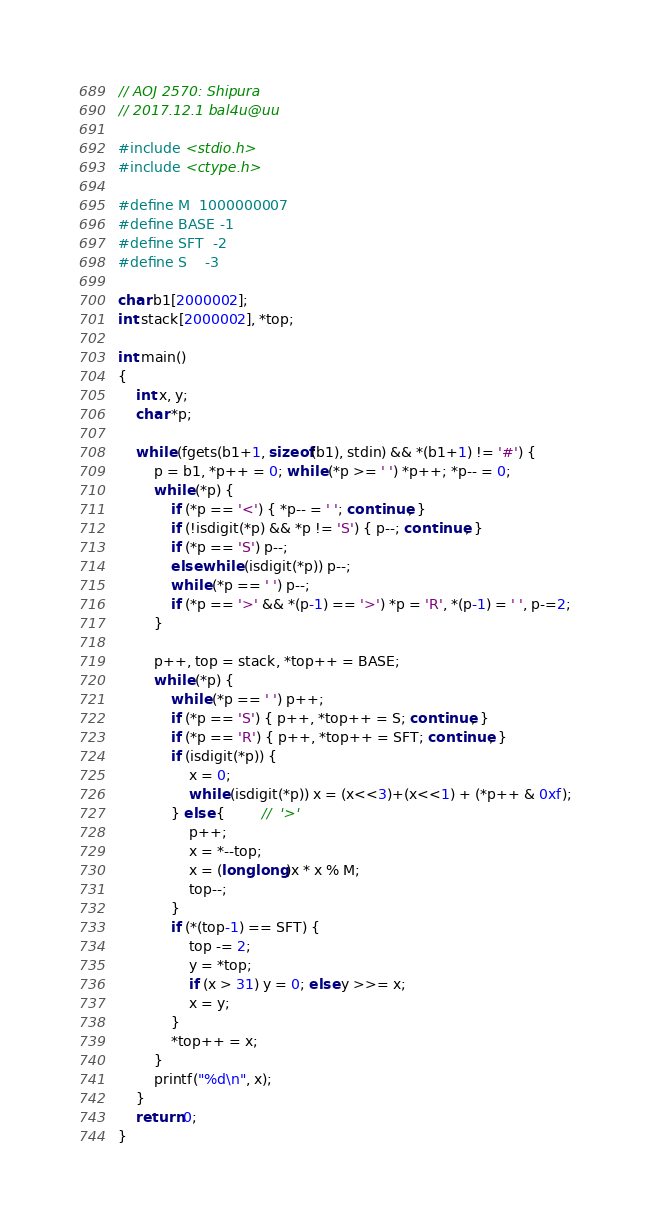<code> <loc_0><loc_0><loc_500><loc_500><_C_>// AOJ 2570: Shipura
// 2017.12.1 bal4u@uu

#include <stdio.h>
#include <ctype.h>

#define M  1000000007
#define BASE -1
#define SFT  -2
#define S    -3

char b1[2000002];
int stack[2000002], *top;

int main()
{
	int x, y;
	char *p;

	while (fgets(b1+1, sizeof(b1), stdin) && *(b1+1) != '#') {
		p = b1, *p++ = 0; while (*p >= ' ') *p++; *p-- = 0;
		while (*p) {
			if (*p == '<') { *p-- = ' '; continue; }
			if (!isdigit(*p) && *p != 'S') { p--; continue; }
			if (*p == 'S') p--;
			else while (isdigit(*p)) p--;
			while (*p == ' ') p--;
			if (*p == '>' && *(p-1) == '>') *p = 'R', *(p-1) = ' ', p-=2;
		}

		p++, top = stack, *top++ = BASE;
		while (*p) {
			while (*p == ' ') p++;
			if (*p == 'S') { p++, *top++ = S; continue; }
			if (*p == 'R') { p++, *top++ = SFT; continue; }
			if (isdigit(*p)) {
				x = 0;
				while (isdigit(*p)) x = (x<<3)+(x<<1) + (*p++ & 0xf);
			} else {		//  '>'
				p++;
				x = *--top;
				x = (long long)x * x % M;
				top--;
			}
			if (*(top-1) == SFT) {
				top -= 2;
				y = *top;
				if (x > 31) y = 0; else y >>= x;
				x = y;
			}
			*top++ = x;
		}
		printf("%d\n", x);
	}
	return 0;
}</code> 